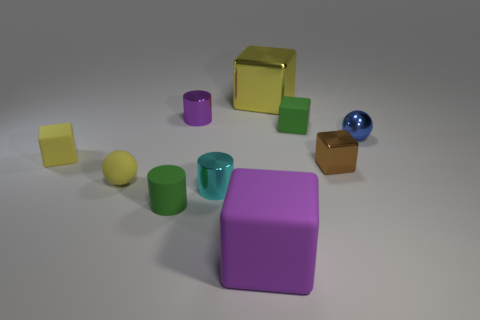Subtract all metallic cylinders. How many cylinders are left? 1 Subtract all cyan cylinders. How many yellow cubes are left? 2 Subtract all green blocks. How many blocks are left? 4 Subtract all red blocks. Subtract all gray balls. How many blocks are left? 5 Subtract all spheres. How many objects are left? 8 Subtract all small rubber cubes. Subtract all small metallic cylinders. How many objects are left? 6 Add 3 blue things. How many blue things are left? 4 Add 3 cylinders. How many cylinders exist? 6 Subtract 0 blue blocks. How many objects are left? 10 